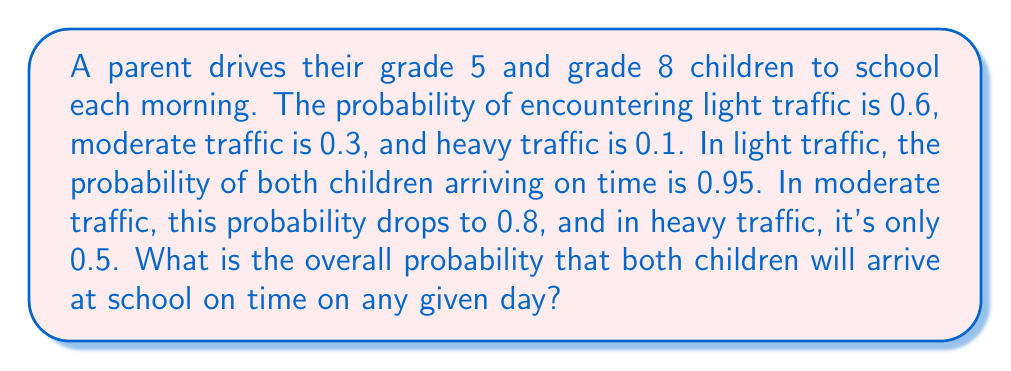Provide a solution to this math problem. Let's approach this step-by-step using the law of total probability:

1) Define events:
   A: Both children arrive on time
   L: Light traffic
   M: Moderate traffic
   H: Heavy traffic

2) We're given:
   $P(L) = 0.6$, $P(M) = 0.3$, $P(H) = 0.1$
   $P(A|L) = 0.95$, $P(A|M) = 0.8$, $P(A|H) = 0.5$

3) The law of total probability states:
   $$P(A) = P(A|L)P(L) + P(A|M)P(M) + P(A|H)P(H)$$

4) Substituting the values:
   $$P(A) = (0.95)(0.6) + (0.8)(0.3) + (0.5)(0.1)$$

5) Calculating:
   $$P(A) = 0.57 + 0.24 + 0.05 = 0.86$$

Therefore, the probability that both children will arrive at school on time on any given day is 0.86 or 86%.
Answer: 0.86 